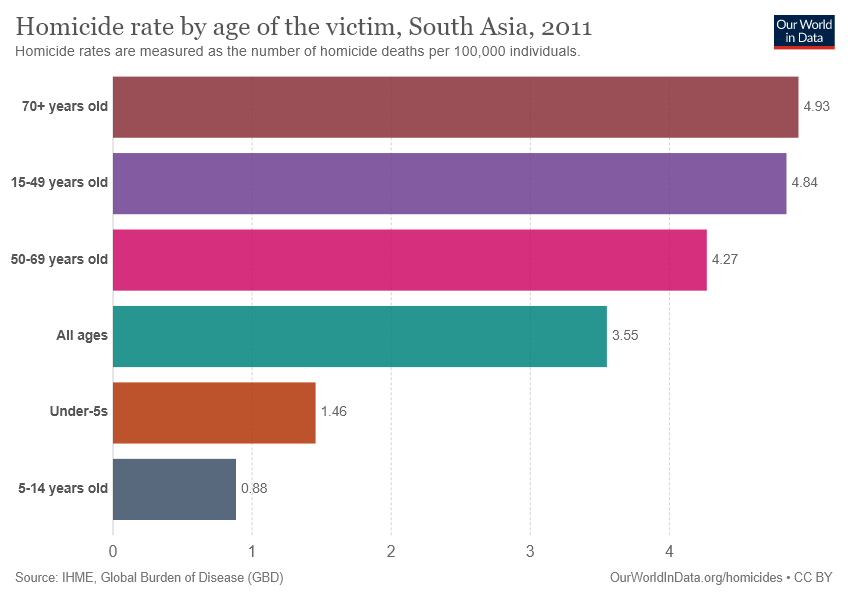Outline some significant characteristics in this image. The chart displays the number of victims in each age group. The difference between the highest and the second highest values in the bar graph is 0.09. 